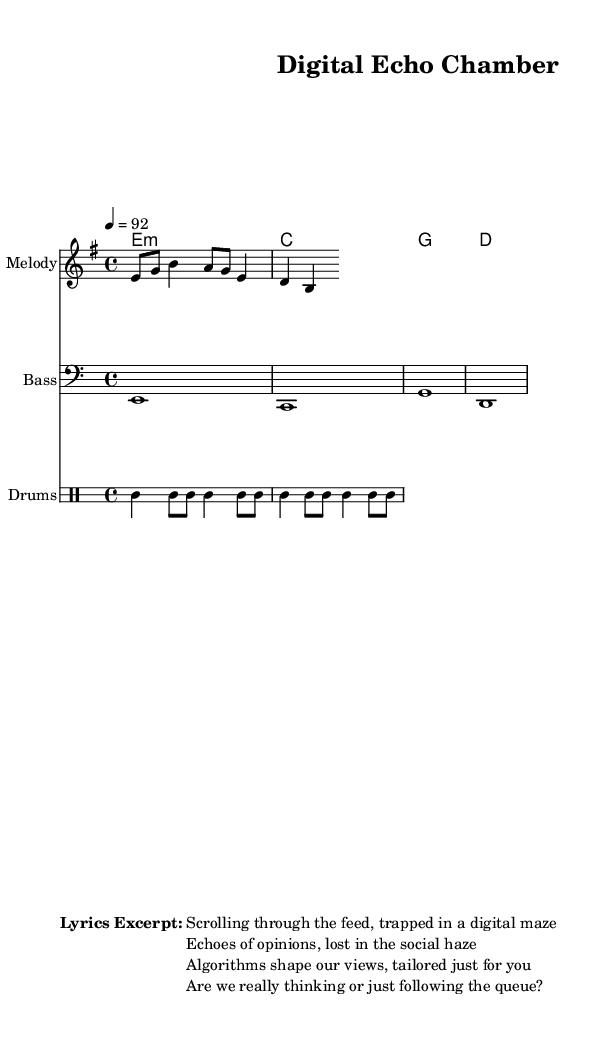What is the key signature of this music? The key signature is E minor, which typically contains one sharp (F#) and establishes the tonal center of the piece.
Answer: E minor What is the time signature of this music? The time signature is 4/4, indicating there are four beats in each measure and the quarter note gets one beat, a common time signature in music.
Answer: 4/4 What is the tempo of the piece? The tempo is marked as 92 beats per minute, indicating the speed at which the music should be played.
Answer: 92 How many beats are in a measure? Since it’s in 4/4 time, each measure has four beats.
Answer: 4 What is the main theme reflected in the lyrics? The lyrics discuss the influence of social media on individual thought and communication, highlighting themes of echo chambers and algorithm-driven views.
Answer: Influence of social media What type of rap does this piece represent? This music represents conscious rap, which focuses on social issues and promotes awareness of critical topics affecting society.
Answer: Conscious rap What instrument plays the bass line? The bass line is written for the bass instrument, providing harmonic support and depth to the piece.
Answer: Bass 